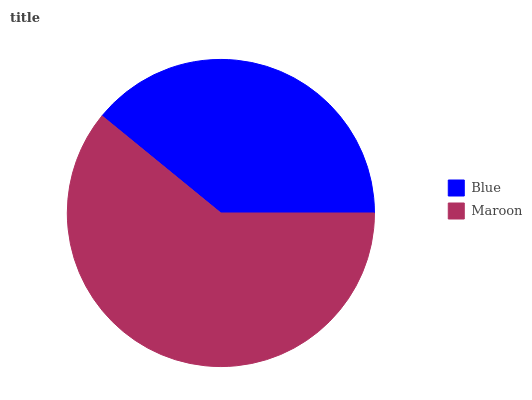Is Blue the minimum?
Answer yes or no. Yes. Is Maroon the maximum?
Answer yes or no. Yes. Is Maroon the minimum?
Answer yes or no. No. Is Maroon greater than Blue?
Answer yes or no. Yes. Is Blue less than Maroon?
Answer yes or no. Yes. Is Blue greater than Maroon?
Answer yes or no. No. Is Maroon less than Blue?
Answer yes or no. No. Is Maroon the high median?
Answer yes or no. Yes. Is Blue the low median?
Answer yes or no. Yes. Is Blue the high median?
Answer yes or no. No. Is Maroon the low median?
Answer yes or no. No. 